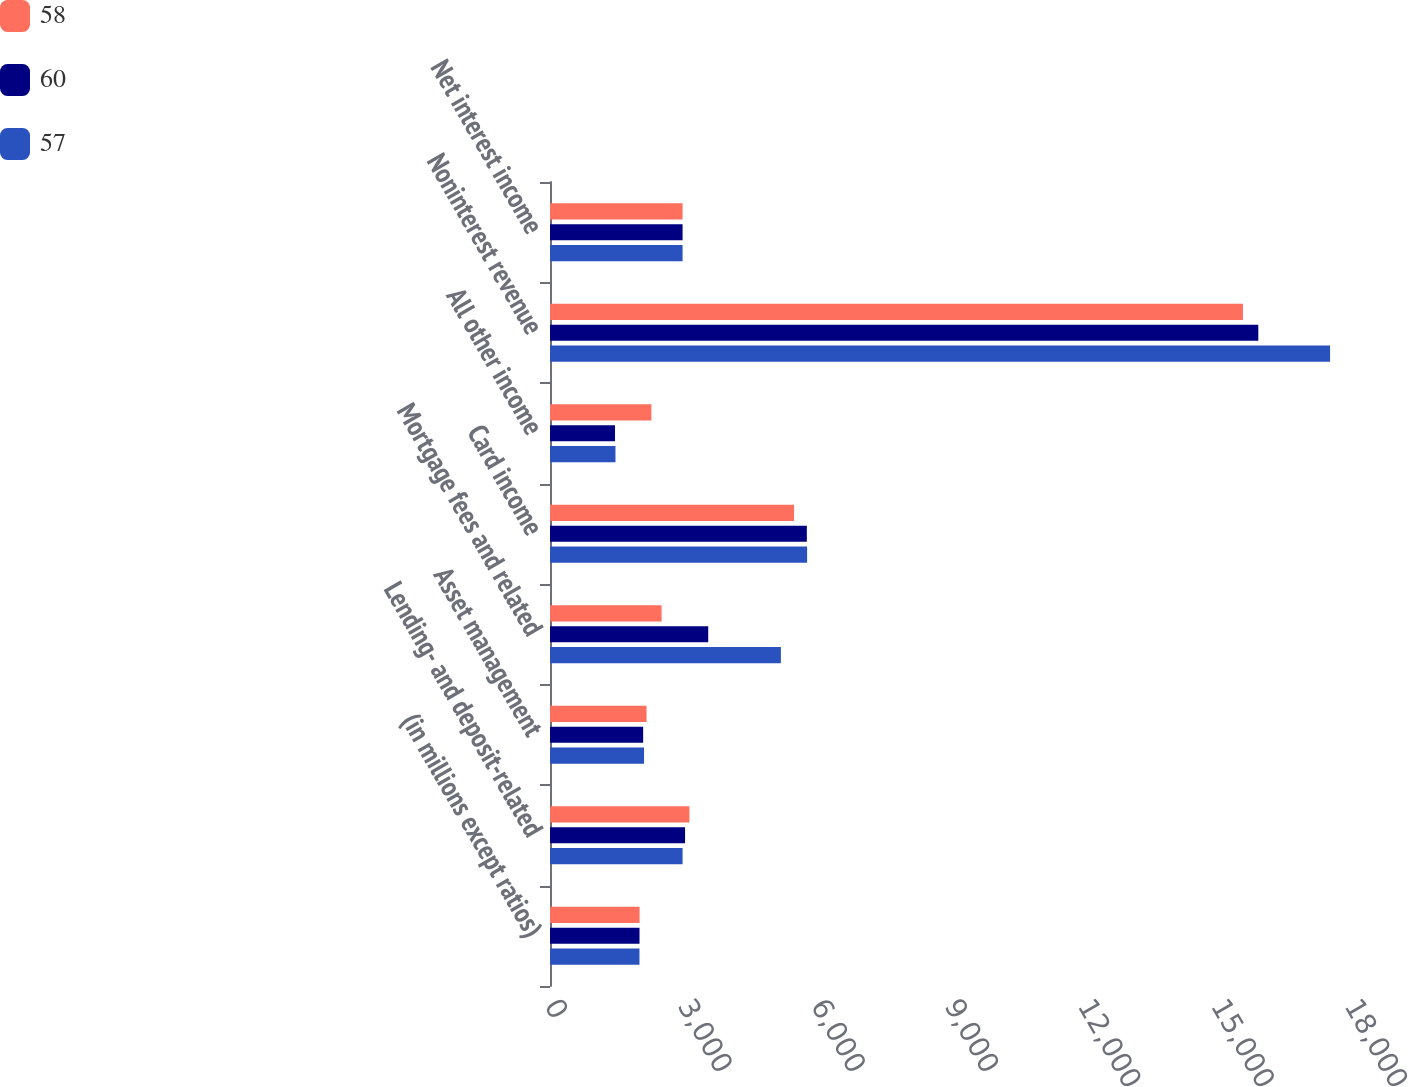Convert chart to OTSL. <chart><loc_0><loc_0><loc_500><loc_500><stacked_bar_chart><ecel><fcel>(in millions except ratios)<fcel>Lending- and deposit-related<fcel>Asset management<fcel>Mortgage fees and related<fcel>Card income<fcel>All other income<fcel>Noninterest revenue<fcel>Net interest income<nl><fcel>58<fcel>2015<fcel>3137<fcel>2172<fcel>2511<fcel>5491<fcel>2281<fcel>15592<fcel>2983<nl><fcel>60<fcel>2014<fcel>3039<fcel>2096<fcel>3560<fcel>5779<fcel>1463<fcel>15937<fcel>2983<nl><fcel>57<fcel>2013<fcel>2983<fcel>2116<fcel>5195<fcel>5785<fcel>1473<fcel>17552<fcel>2983<nl></chart> 